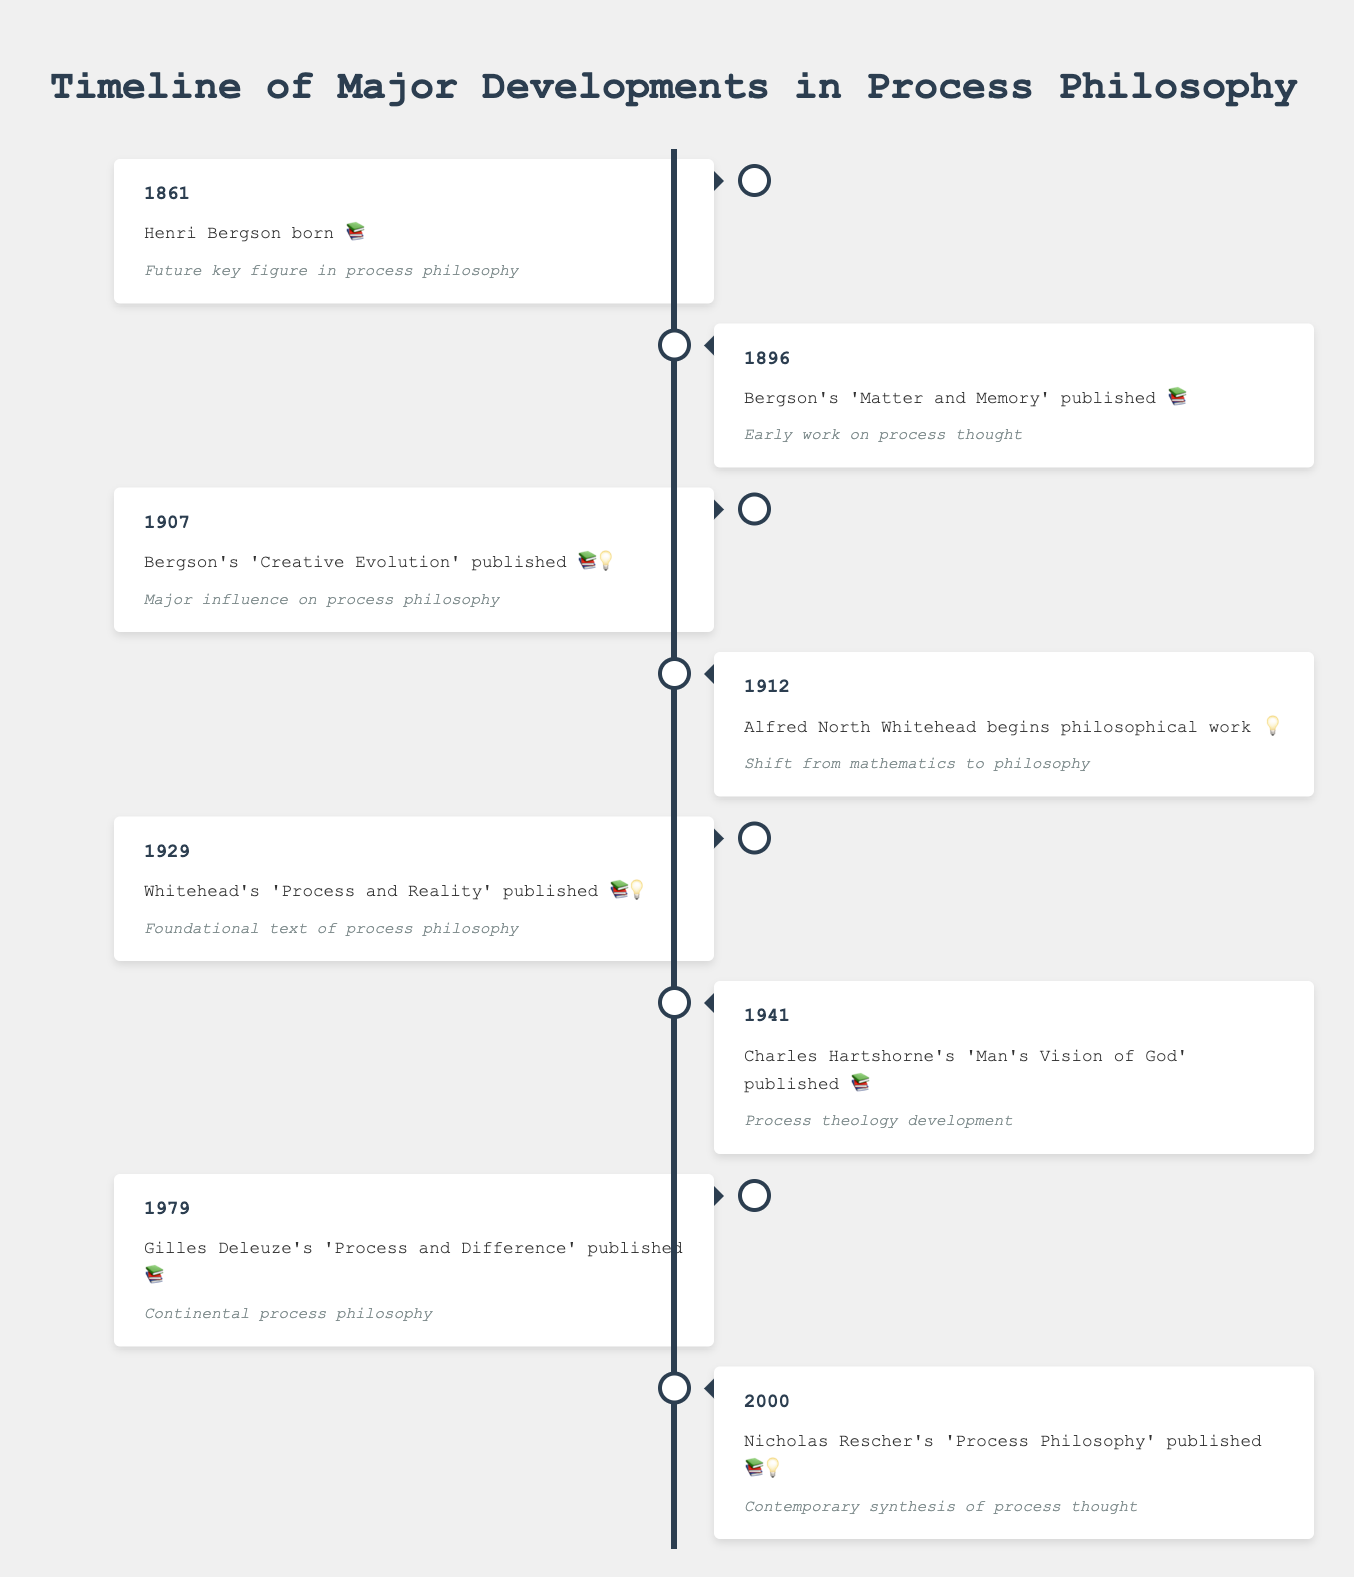What is the title of the timeline? The title is normally located at the top of the figure. Simply reading the text at the top of the figure gives the title.
Answer: Timeline of Major Developments in Process Philosophy When was Henri Bergson born? Look at the left side of the timeline under the year 1861; the event mentions Henri Bergson's birth.
Answer: 1861 Which book by Bergson published in 1907 had a major influence on process philosophy? Locate the year 1907 on the left side and read the event and its significance. The book mentioned is 'Creative Evolution'.
Answer: 'Creative Evolution' How many events are listed between 1861 and 1941? Count the events listed in the figure from the first event in 1861 to the event in 1941. The events are in the years 1861, 1896, 1907, 1912, 1929, and 1941.
Answer: 6 What significant shift did Alfred North Whitehead make in 1912? Finding the year 1912 on the right side of the timeline and reading the event description indicates the significant shift.
Answer: Shift from mathematics to philosophy Which event is considered the foundational text of process philosophy, and when was it published? Locate the event on the left side of the timeline marked with both a book and a lightbulb emoji closest to this description. The event is in 1929, titled 'Process and Reality' by Whitehead.
Answer: 'Process and Reality' published in 1929 Compare the significance of Bergson's 'Matter and Memory' and Whitehead's 'Process and Reality'. Reading the entries for 'Matter and Memory' (1896) and 'Process and Reality' (1929) on the timeline identifies how they are described. 'Matter and Memory' is noted as an early work on process thought, while 'Process and Reality' is the foundational text.
Answer: 'Matter and Memory' is an early work; 'Process and Reality' is a foundational text Who contributed to process philosophy in the year 2000, and what was the work? Finding the year 2000 on the right side of the timeline and reading the event details reveals this information.
Answer: Nicholas Rescher, 'Process Philosophy' Which philosophers’ works from the list were published in the 20th century? Identify the events that fall between 1901 and 2000 and list each philosopher and their work.
Answer: Bergson, Whitehead, Hartshorne, Deleuze What type of philosophies does the timeline highlight based on the significant events? By reading through the significance sections for each event, identify the recurring themes and philosophies, specifically focusing on the terms and ideas presented. The timeline highlights the development of process thought and its various expressions through works on process theology, continental process philosophy, and contemporary synthesis.
Answer: Process thought, process theology, continental process philosophy, contemporary synthesis 